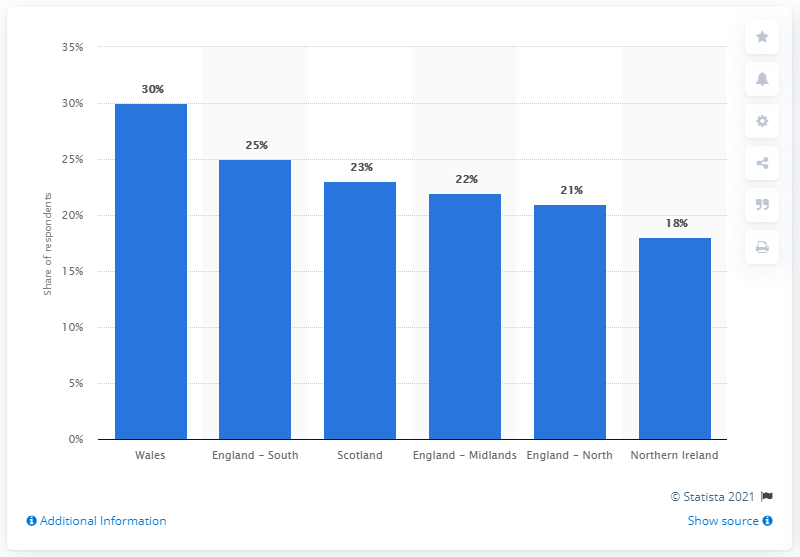Indicate a few pertinent items in this graphic. In Wales, 30% of respondents plan to spend more on gifts for others this year compared to last year. 